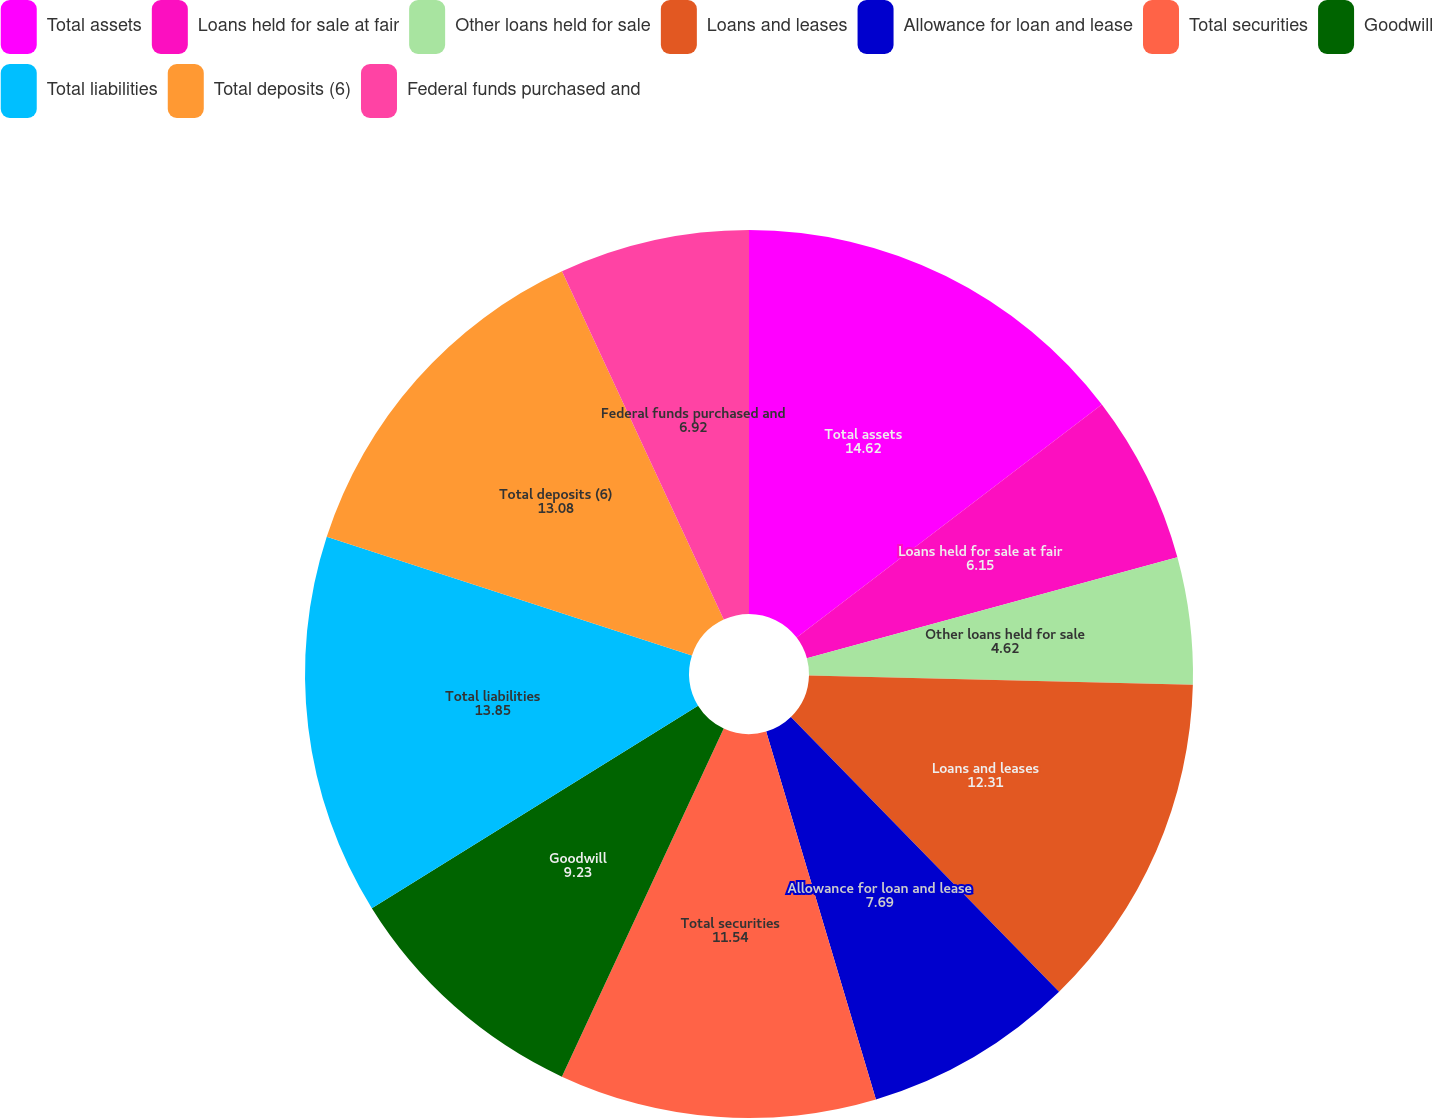Convert chart to OTSL. <chart><loc_0><loc_0><loc_500><loc_500><pie_chart><fcel>Total assets<fcel>Loans held for sale at fair<fcel>Other loans held for sale<fcel>Loans and leases<fcel>Allowance for loan and lease<fcel>Total securities<fcel>Goodwill<fcel>Total liabilities<fcel>Total deposits (6)<fcel>Federal funds purchased and<nl><fcel>14.62%<fcel>6.15%<fcel>4.62%<fcel>12.31%<fcel>7.69%<fcel>11.54%<fcel>9.23%<fcel>13.85%<fcel>13.08%<fcel>6.92%<nl></chart> 